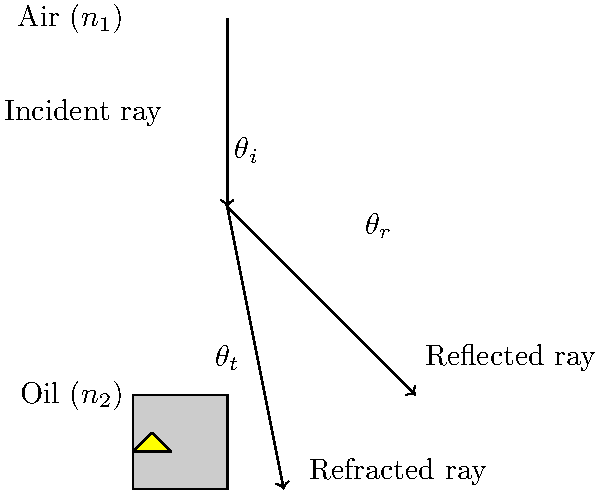During a Nepalese ritual, you observe a ceremonial oil lamp and notice how light interacts with the oil surface. If the refractive index of air ($n_1$) is 1.00 and the refractive index of the oil ($n_2$) is 1.47, what is the critical angle for total internal reflection at the oil-air interface? Assume the light is traveling from oil to air. To find the critical angle for total internal reflection, we need to follow these steps:

1. Recall Snell's law: $n_1 \sin \theta_1 = n_2 \sin \theta_2$

2. For the critical angle, the refracted ray is parallel to the interface, meaning $\theta_2 = 90°$

3. Substitute these values into Snell's law:
   $n_{oil} \sin \theta_c = n_{air} \sin 90°$

4. Simplify, knowing that $\sin 90° = 1$:
   $1.47 \sin \theta_c = 1.00 \cdot 1$

5. Solve for $\theta_c$:
   $\sin \theta_c = \frac{1.00}{1.47}$

6. Take the inverse sine (arcsin) of both sides:
   $\theta_c = \arcsin(\frac{1.00}{1.47})$

7. Calculate the result:
   $\theta_c \approx 42.9°$

Therefore, the critical angle for total internal reflection at the oil-air interface is approximately 42.9°.
Answer: 42.9° 